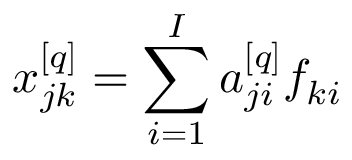Convert formula to latex. <formula><loc_0><loc_0><loc_500><loc_500>x _ { j k } ^ { [ q ] } = \sum _ { i = 1 } ^ { I } a _ { j i } ^ { [ q ] } f _ { k i }</formula> 